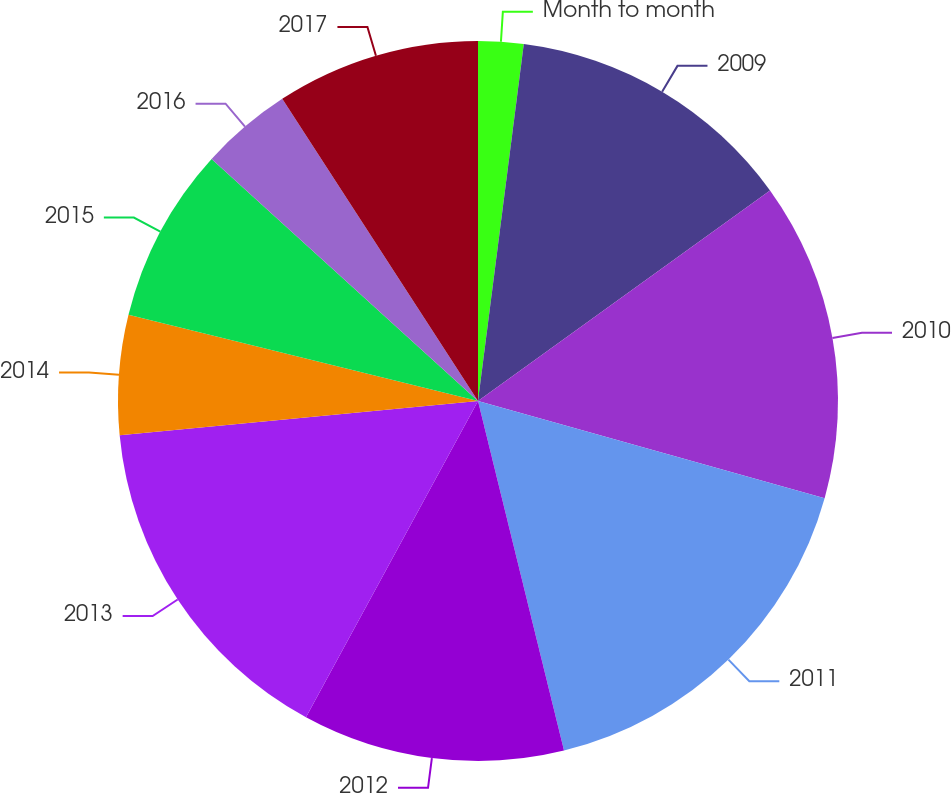Convert chart to OTSL. <chart><loc_0><loc_0><loc_500><loc_500><pie_chart><fcel>Month to month<fcel>2009<fcel>2010<fcel>2011<fcel>2012<fcel>2013<fcel>2014<fcel>2015<fcel>2016<fcel>2017<nl><fcel>2.03%<fcel>13.03%<fcel>14.29%<fcel>16.81%<fcel>11.77%<fcel>15.55%<fcel>5.37%<fcel>7.89%<fcel>4.11%<fcel>9.15%<nl></chart> 